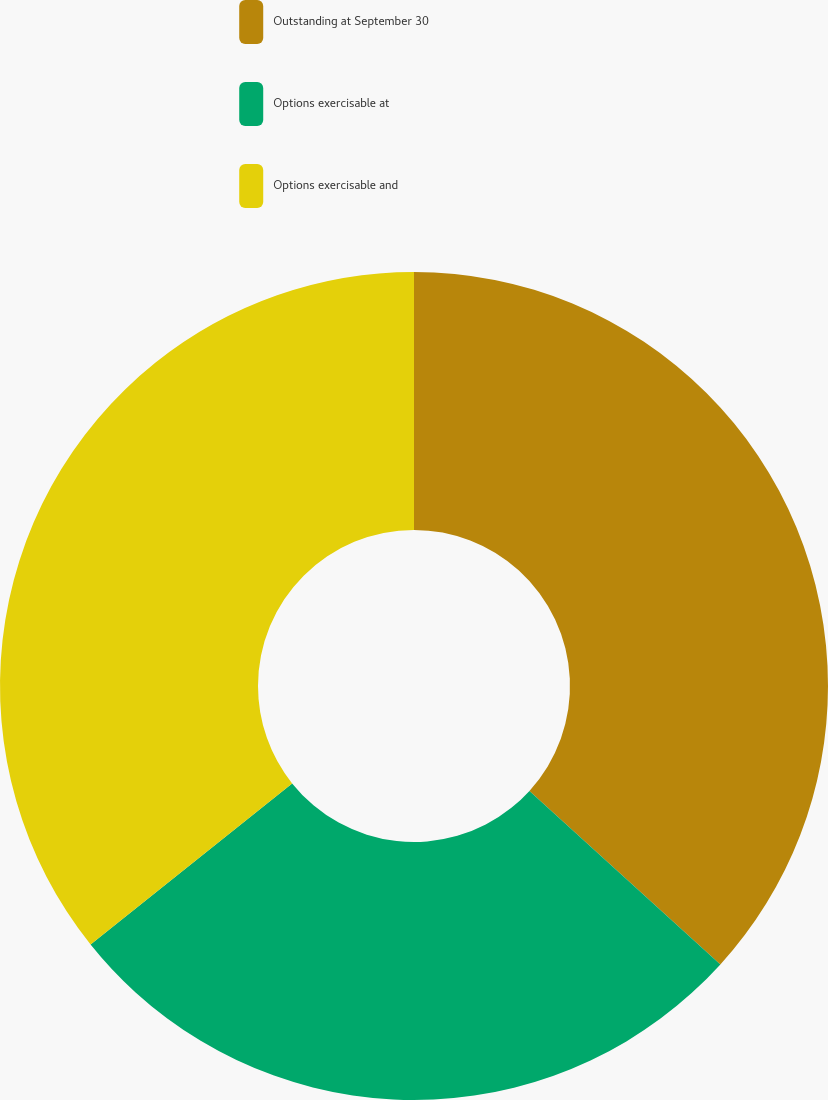<chart> <loc_0><loc_0><loc_500><loc_500><pie_chart><fcel>Outstanding at September 30<fcel>Options exercisable at<fcel>Options exercisable and<nl><fcel>36.74%<fcel>27.53%<fcel>35.73%<nl></chart> 